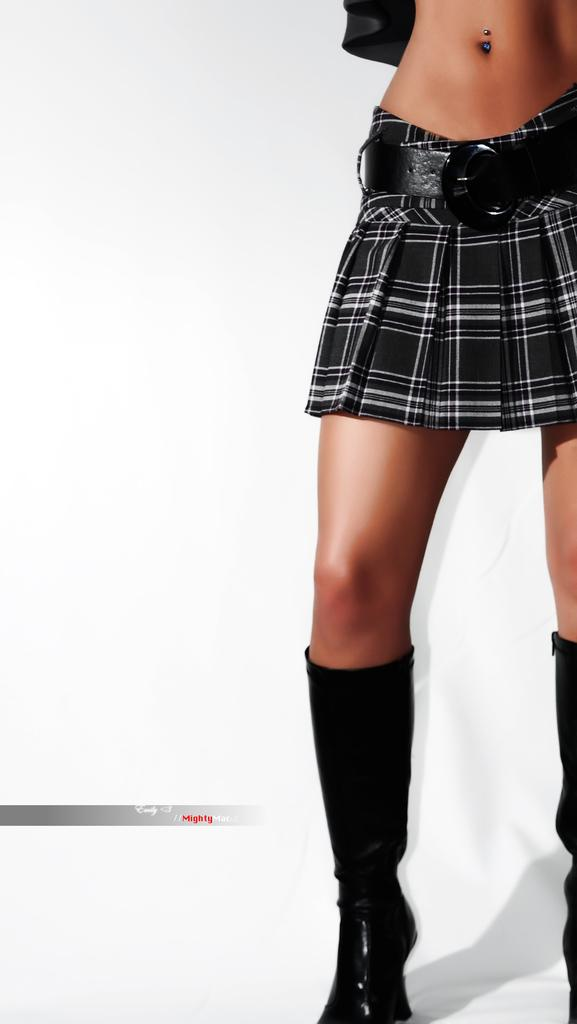What part of a person can be seen in the image? There are legs of a person in the image. On which side of the image are the legs located? The legs are on the right side of the image. What type of insurance policy is being discussed in the image? There is no mention of insurance in the image; it only shows legs of a person. What is the color of the wall behind the legs in the image? There is no wall visible in the image; it only shows legs of a person. 